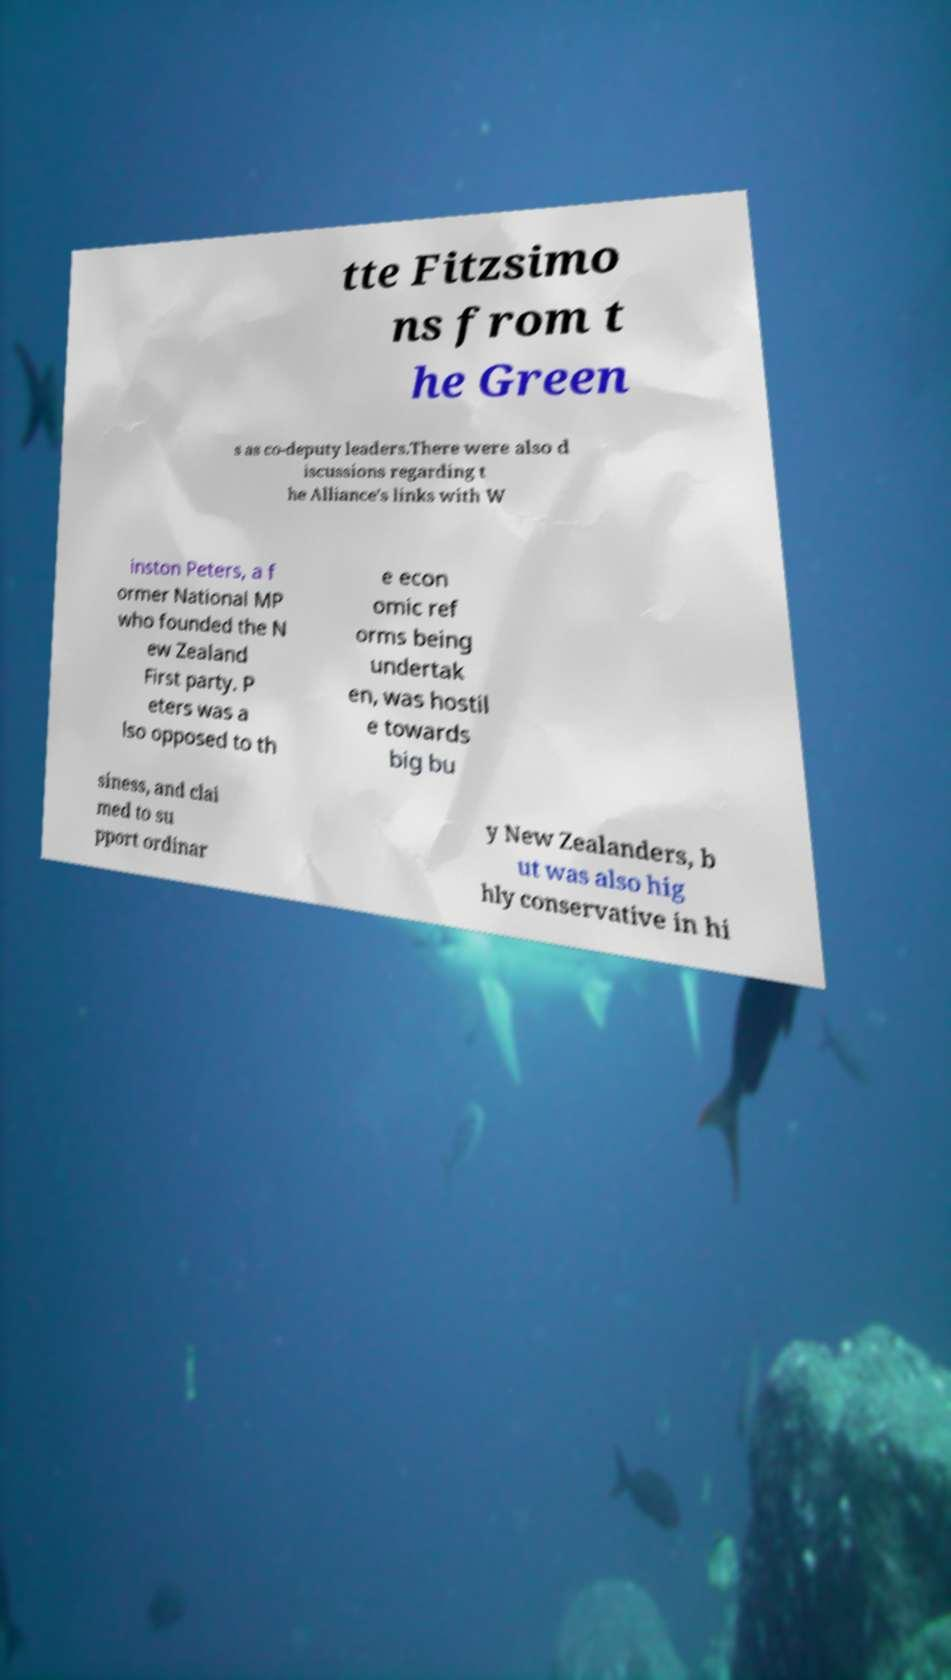What messages or text are displayed in this image? I need them in a readable, typed format. tte Fitzsimo ns from t he Green s as co-deputy leaders.There were also d iscussions regarding t he Alliance's links with W inston Peters, a f ormer National MP who founded the N ew Zealand First party. P eters was a lso opposed to th e econ omic ref orms being undertak en, was hostil e towards big bu siness, and clai med to su pport ordinar y New Zealanders, b ut was also hig hly conservative in hi 